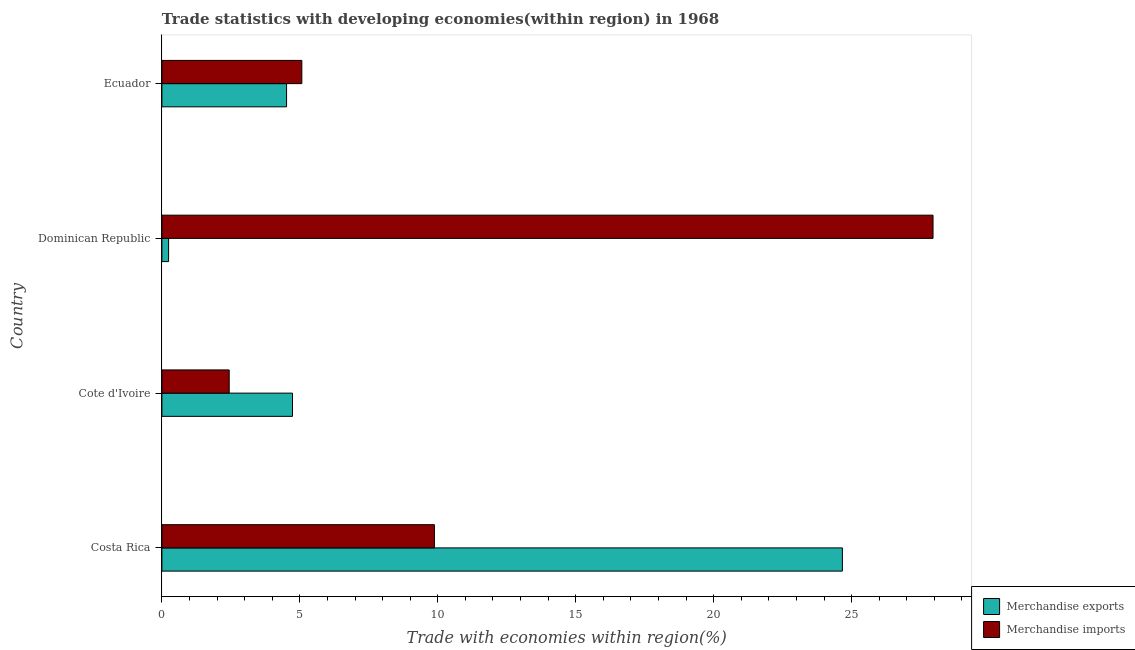How many groups of bars are there?
Provide a succinct answer. 4. Are the number of bars on each tick of the Y-axis equal?
Keep it short and to the point. Yes. What is the label of the 2nd group of bars from the top?
Give a very brief answer. Dominican Republic. In how many cases, is the number of bars for a given country not equal to the number of legend labels?
Keep it short and to the point. 0. What is the merchandise exports in Dominican Republic?
Ensure brevity in your answer.  0.24. Across all countries, what is the maximum merchandise imports?
Provide a short and direct response. 27.95. Across all countries, what is the minimum merchandise exports?
Ensure brevity in your answer.  0.24. In which country was the merchandise imports minimum?
Provide a short and direct response. Cote d'Ivoire. What is the total merchandise imports in the graph?
Your response must be concise. 45.34. What is the difference between the merchandise imports in Cote d'Ivoire and that in Dominican Republic?
Offer a very short reply. -25.51. What is the difference between the merchandise exports in Ecuador and the merchandise imports in Costa Rica?
Keep it short and to the point. -5.36. What is the average merchandise exports per country?
Give a very brief answer. 8.54. What is the difference between the merchandise imports and merchandise exports in Costa Rica?
Keep it short and to the point. -14.79. In how many countries, is the merchandise imports greater than 28 %?
Provide a short and direct response. 0. What is the ratio of the merchandise exports in Cote d'Ivoire to that in Dominican Republic?
Give a very brief answer. 19.52. What is the difference between the highest and the second highest merchandise imports?
Offer a very short reply. 18.07. What is the difference between the highest and the lowest merchandise exports?
Provide a succinct answer. 24.42. In how many countries, is the merchandise imports greater than the average merchandise imports taken over all countries?
Provide a short and direct response. 1. Are all the bars in the graph horizontal?
Your answer should be compact. Yes. How many countries are there in the graph?
Give a very brief answer. 4. How many legend labels are there?
Your answer should be compact. 2. How are the legend labels stacked?
Provide a short and direct response. Vertical. What is the title of the graph?
Your answer should be compact. Trade statistics with developing economies(within region) in 1968. What is the label or title of the X-axis?
Ensure brevity in your answer.  Trade with economies within region(%). What is the Trade with economies within region(%) of Merchandise exports in Costa Rica?
Make the answer very short. 24.67. What is the Trade with economies within region(%) of Merchandise imports in Costa Rica?
Your response must be concise. 9.88. What is the Trade with economies within region(%) of Merchandise exports in Cote d'Ivoire?
Provide a short and direct response. 4.73. What is the Trade with economies within region(%) in Merchandise imports in Cote d'Ivoire?
Offer a very short reply. 2.44. What is the Trade with economies within region(%) of Merchandise exports in Dominican Republic?
Offer a very short reply. 0.24. What is the Trade with economies within region(%) in Merchandise imports in Dominican Republic?
Ensure brevity in your answer.  27.95. What is the Trade with economies within region(%) of Merchandise exports in Ecuador?
Your answer should be compact. 4.52. What is the Trade with economies within region(%) of Merchandise imports in Ecuador?
Provide a succinct answer. 5.07. Across all countries, what is the maximum Trade with economies within region(%) of Merchandise exports?
Make the answer very short. 24.67. Across all countries, what is the maximum Trade with economies within region(%) in Merchandise imports?
Your answer should be very brief. 27.95. Across all countries, what is the minimum Trade with economies within region(%) in Merchandise exports?
Your answer should be compact. 0.24. Across all countries, what is the minimum Trade with economies within region(%) of Merchandise imports?
Make the answer very short. 2.44. What is the total Trade with economies within region(%) of Merchandise exports in the graph?
Give a very brief answer. 34.16. What is the total Trade with economies within region(%) in Merchandise imports in the graph?
Your answer should be compact. 45.34. What is the difference between the Trade with economies within region(%) of Merchandise exports in Costa Rica and that in Cote d'Ivoire?
Your response must be concise. 19.93. What is the difference between the Trade with economies within region(%) in Merchandise imports in Costa Rica and that in Cote d'Ivoire?
Offer a very short reply. 7.44. What is the difference between the Trade with economies within region(%) in Merchandise exports in Costa Rica and that in Dominican Republic?
Offer a very short reply. 24.42. What is the difference between the Trade with economies within region(%) of Merchandise imports in Costa Rica and that in Dominican Republic?
Offer a very short reply. -18.07. What is the difference between the Trade with economies within region(%) in Merchandise exports in Costa Rica and that in Ecuador?
Keep it short and to the point. 20.15. What is the difference between the Trade with economies within region(%) of Merchandise imports in Costa Rica and that in Ecuador?
Your response must be concise. 4.81. What is the difference between the Trade with economies within region(%) of Merchandise exports in Cote d'Ivoire and that in Dominican Republic?
Ensure brevity in your answer.  4.49. What is the difference between the Trade with economies within region(%) of Merchandise imports in Cote d'Ivoire and that in Dominican Republic?
Your answer should be very brief. -25.51. What is the difference between the Trade with economies within region(%) of Merchandise exports in Cote d'Ivoire and that in Ecuador?
Give a very brief answer. 0.22. What is the difference between the Trade with economies within region(%) in Merchandise imports in Cote d'Ivoire and that in Ecuador?
Provide a short and direct response. -2.63. What is the difference between the Trade with economies within region(%) of Merchandise exports in Dominican Republic and that in Ecuador?
Offer a very short reply. -4.28. What is the difference between the Trade with economies within region(%) of Merchandise imports in Dominican Republic and that in Ecuador?
Give a very brief answer. 22.88. What is the difference between the Trade with economies within region(%) of Merchandise exports in Costa Rica and the Trade with economies within region(%) of Merchandise imports in Cote d'Ivoire?
Give a very brief answer. 22.23. What is the difference between the Trade with economies within region(%) of Merchandise exports in Costa Rica and the Trade with economies within region(%) of Merchandise imports in Dominican Republic?
Your response must be concise. -3.29. What is the difference between the Trade with economies within region(%) in Merchandise exports in Costa Rica and the Trade with economies within region(%) in Merchandise imports in Ecuador?
Provide a short and direct response. 19.59. What is the difference between the Trade with economies within region(%) of Merchandise exports in Cote d'Ivoire and the Trade with economies within region(%) of Merchandise imports in Dominican Republic?
Ensure brevity in your answer.  -23.22. What is the difference between the Trade with economies within region(%) of Merchandise exports in Cote d'Ivoire and the Trade with economies within region(%) of Merchandise imports in Ecuador?
Ensure brevity in your answer.  -0.34. What is the difference between the Trade with economies within region(%) of Merchandise exports in Dominican Republic and the Trade with economies within region(%) of Merchandise imports in Ecuador?
Offer a terse response. -4.83. What is the average Trade with economies within region(%) in Merchandise exports per country?
Ensure brevity in your answer.  8.54. What is the average Trade with economies within region(%) in Merchandise imports per country?
Offer a terse response. 11.33. What is the difference between the Trade with economies within region(%) of Merchandise exports and Trade with economies within region(%) of Merchandise imports in Costa Rica?
Offer a terse response. 14.79. What is the difference between the Trade with economies within region(%) in Merchandise exports and Trade with economies within region(%) in Merchandise imports in Cote d'Ivoire?
Make the answer very short. 2.29. What is the difference between the Trade with economies within region(%) in Merchandise exports and Trade with economies within region(%) in Merchandise imports in Dominican Republic?
Your answer should be compact. -27.71. What is the difference between the Trade with economies within region(%) of Merchandise exports and Trade with economies within region(%) of Merchandise imports in Ecuador?
Your answer should be compact. -0.55. What is the ratio of the Trade with economies within region(%) in Merchandise exports in Costa Rica to that in Cote d'Ivoire?
Ensure brevity in your answer.  5.21. What is the ratio of the Trade with economies within region(%) in Merchandise imports in Costa Rica to that in Cote d'Ivoire?
Offer a terse response. 4.05. What is the ratio of the Trade with economies within region(%) of Merchandise exports in Costa Rica to that in Dominican Republic?
Give a very brief answer. 101.71. What is the ratio of the Trade with economies within region(%) of Merchandise imports in Costa Rica to that in Dominican Republic?
Give a very brief answer. 0.35. What is the ratio of the Trade with economies within region(%) of Merchandise exports in Costa Rica to that in Ecuador?
Give a very brief answer. 5.46. What is the ratio of the Trade with economies within region(%) in Merchandise imports in Costa Rica to that in Ecuador?
Offer a terse response. 1.95. What is the ratio of the Trade with economies within region(%) of Merchandise exports in Cote d'Ivoire to that in Dominican Republic?
Offer a terse response. 19.52. What is the ratio of the Trade with economies within region(%) of Merchandise imports in Cote d'Ivoire to that in Dominican Republic?
Offer a very short reply. 0.09. What is the ratio of the Trade with economies within region(%) in Merchandise exports in Cote d'Ivoire to that in Ecuador?
Your answer should be very brief. 1.05. What is the ratio of the Trade with economies within region(%) of Merchandise imports in Cote d'Ivoire to that in Ecuador?
Provide a short and direct response. 0.48. What is the ratio of the Trade with economies within region(%) in Merchandise exports in Dominican Republic to that in Ecuador?
Your answer should be compact. 0.05. What is the ratio of the Trade with economies within region(%) of Merchandise imports in Dominican Republic to that in Ecuador?
Your answer should be compact. 5.51. What is the difference between the highest and the second highest Trade with economies within region(%) of Merchandise exports?
Make the answer very short. 19.93. What is the difference between the highest and the second highest Trade with economies within region(%) in Merchandise imports?
Keep it short and to the point. 18.07. What is the difference between the highest and the lowest Trade with economies within region(%) of Merchandise exports?
Offer a very short reply. 24.42. What is the difference between the highest and the lowest Trade with economies within region(%) of Merchandise imports?
Your answer should be compact. 25.51. 